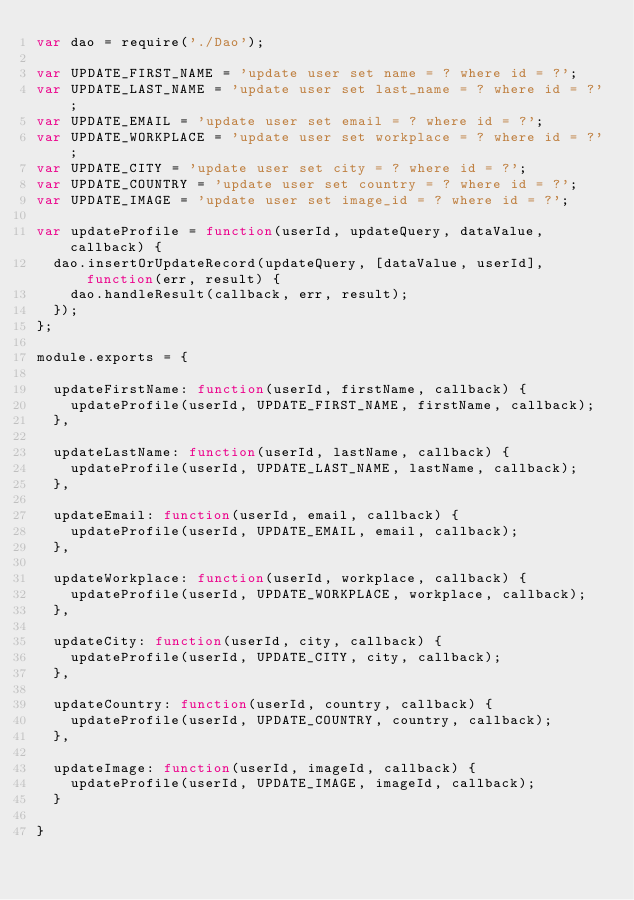<code> <loc_0><loc_0><loc_500><loc_500><_JavaScript_>var dao = require('./Dao');

var UPDATE_FIRST_NAME = 'update user set name = ? where id = ?';
var UPDATE_LAST_NAME = 'update user set last_name = ? where id = ?';
var UPDATE_EMAIL = 'update user set email = ? where id = ?';
var UPDATE_WORKPLACE = 'update user set workplace = ? where id = ?';
var UPDATE_CITY = 'update user set city = ? where id = ?';
var UPDATE_COUNTRY = 'update user set country = ? where id = ?';
var UPDATE_IMAGE = 'update user set image_id = ? where id = ?';

var updateProfile = function(userId, updateQuery, dataValue, callback) {
	dao.insertOrUpdateRecord(updateQuery, [dataValue, userId], function(err, result) {
		dao.handleResult(callback, err, result);
	});
};

module.exports = {

	updateFirstName: function(userId, firstName, callback) {
		updateProfile(userId, UPDATE_FIRST_NAME, firstName, callback);
	},

	updateLastName: function(userId, lastName, callback) {
		updateProfile(userId, UPDATE_LAST_NAME, lastName, callback);
	},

	updateEmail: function(userId, email, callback) {
		updateProfile(userId, UPDATE_EMAIL, email, callback);
	},

	updateWorkplace: function(userId, workplace, callback) {
		updateProfile(userId, UPDATE_WORKPLACE, workplace, callback);
	},

	updateCity: function(userId, city, callback) {
		updateProfile(userId, UPDATE_CITY, city, callback);
	},

	updateCountry: function(userId, country, callback) {
		updateProfile(userId, UPDATE_COUNTRY, country, callback);
	},

	updateImage: function(userId, imageId, callback) {
		updateProfile(userId, UPDATE_IMAGE, imageId, callback);
	}

}</code> 